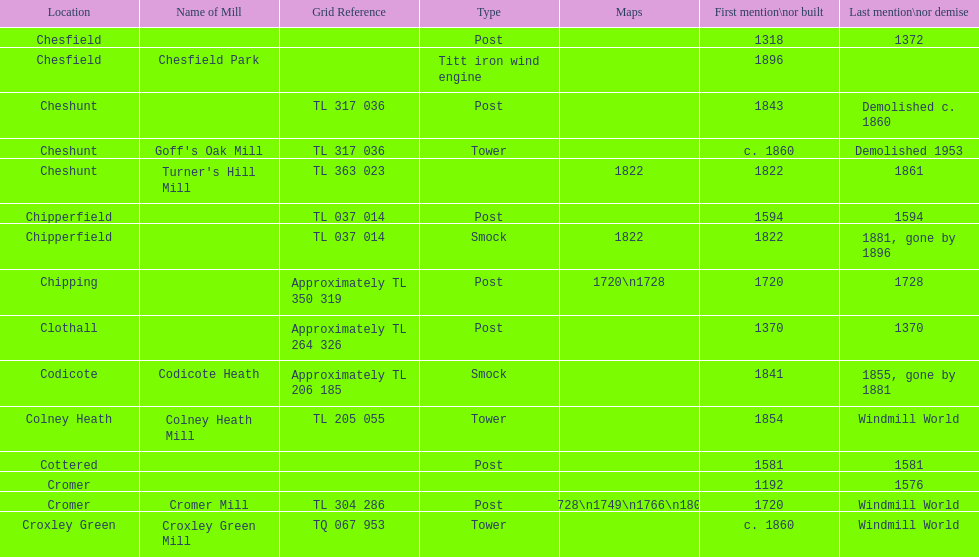What is the total number of mills named cheshunt? 3. 